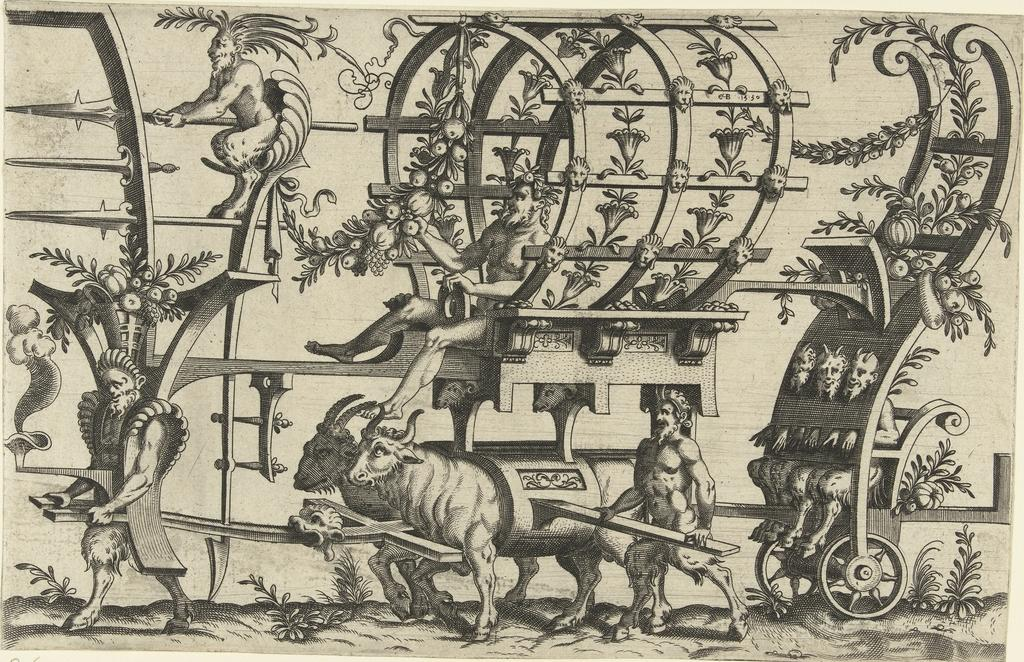What is featured on the poster in the image? The poster contains animals, creepers, and centaurs. Can you describe the animals depicted on the poster? The poster contains animals, but the specific types of animals are not mentioned in the facts. What type of mythical creatures are on the poster? The poster contains centaurs, which are mythical creatures. How many boxes are stacked on top of each other in the image? There is no mention of boxes in the image, so it is not possible to answer this question. 